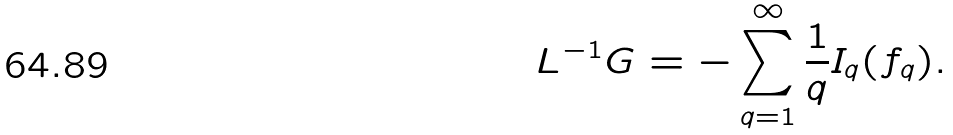Convert formula to latex. <formula><loc_0><loc_0><loc_500><loc_500>L ^ { - 1 } G = - \sum _ { q = 1 } ^ { \infty } \frac { 1 } q I _ { q } ( f _ { q } ) .</formula> 